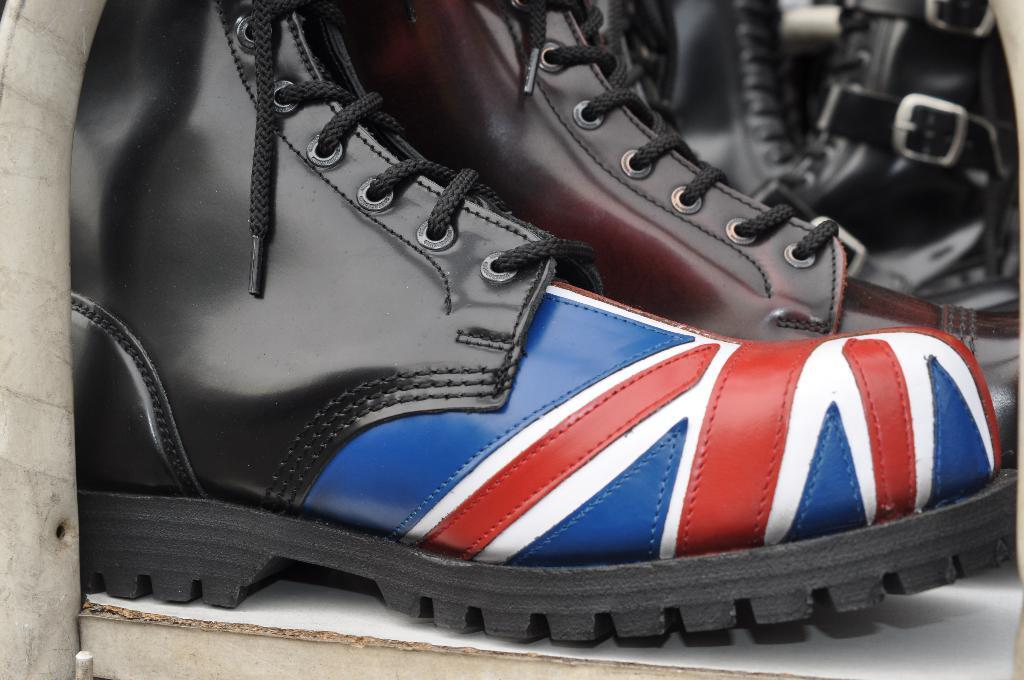What type of footwear is placed on the floor in the image? There are boots on the floor in the image. What object can be seen on the left side of the image? There is a wooden trunk on the left side of the image. What type of branch can be seen cushioning the boots in the image? There is no branch present in the image, and the boots are not being cushioned by any object. How many apples are visible on the wooden trunk in the image? There are no apples present in the image. 